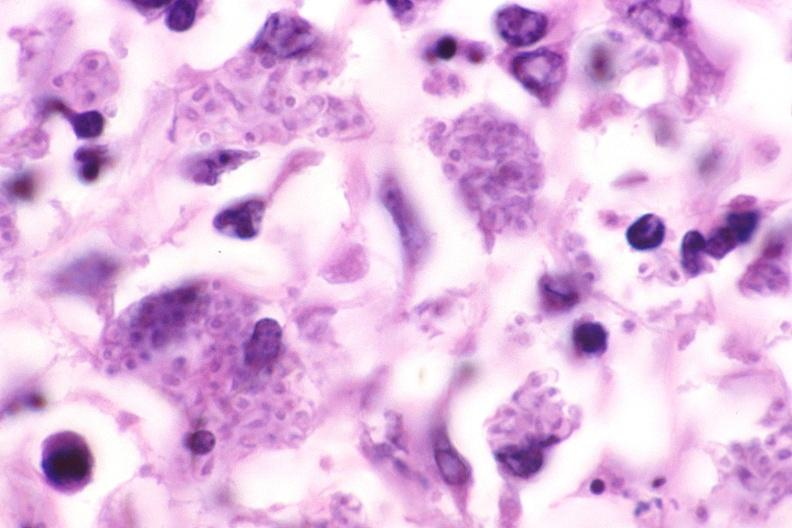does stomach show lung, histoplasma pneumonia?
Answer the question using a single word or phrase. No 